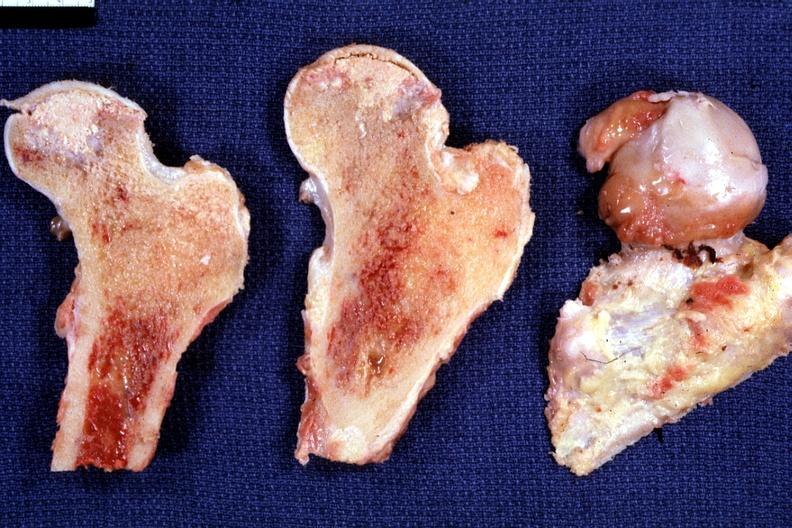what is present?
Answer the question using a single word or phrase. Joints 